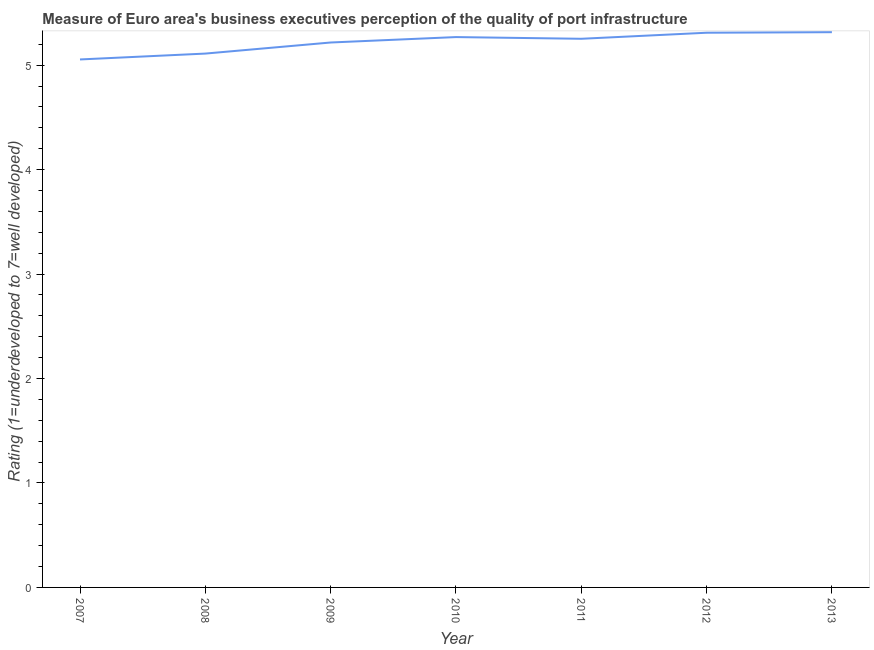What is the rating measuring quality of port infrastructure in 2007?
Your answer should be very brief. 5.05. Across all years, what is the maximum rating measuring quality of port infrastructure?
Provide a short and direct response. 5.32. Across all years, what is the minimum rating measuring quality of port infrastructure?
Make the answer very short. 5.05. In which year was the rating measuring quality of port infrastructure minimum?
Keep it short and to the point. 2007. What is the sum of the rating measuring quality of port infrastructure?
Offer a terse response. 36.53. What is the difference between the rating measuring quality of port infrastructure in 2007 and 2012?
Make the answer very short. -0.26. What is the average rating measuring quality of port infrastructure per year?
Ensure brevity in your answer.  5.22. What is the median rating measuring quality of port infrastructure?
Your response must be concise. 5.25. What is the ratio of the rating measuring quality of port infrastructure in 2007 to that in 2008?
Provide a succinct answer. 0.99. What is the difference between the highest and the second highest rating measuring quality of port infrastructure?
Provide a short and direct response. 0.01. Is the sum of the rating measuring quality of port infrastructure in 2009 and 2010 greater than the maximum rating measuring quality of port infrastructure across all years?
Give a very brief answer. Yes. What is the difference between the highest and the lowest rating measuring quality of port infrastructure?
Provide a short and direct response. 0.26. How many lines are there?
Make the answer very short. 1. How many years are there in the graph?
Your answer should be compact. 7. What is the difference between two consecutive major ticks on the Y-axis?
Ensure brevity in your answer.  1. What is the title of the graph?
Your answer should be compact. Measure of Euro area's business executives perception of the quality of port infrastructure. What is the label or title of the Y-axis?
Provide a short and direct response. Rating (1=underdeveloped to 7=well developed) . What is the Rating (1=underdeveloped to 7=well developed)  in 2007?
Provide a succinct answer. 5.05. What is the Rating (1=underdeveloped to 7=well developed)  of 2008?
Ensure brevity in your answer.  5.11. What is the Rating (1=underdeveloped to 7=well developed)  of 2009?
Offer a terse response. 5.22. What is the Rating (1=underdeveloped to 7=well developed)  in 2010?
Your answer should be compact. 5.27. What is the Rating (1=underdeveloped to 7=well developed)  of 2011?
Provide a succinct answer. 5.25. What is the Rating (1=underdeveloped to 7=well developed)  of 2012?
Your response must be concise. 5.31. What is the Rating (1=underdeveloped to 7=well developed)  of 2013?
Ensure brevity in your answer.  5.32. What is the difference between the Rating (1=underdeveloped to 7=well developed)  in 2007 and 2008?
Ensure brevity in your answer.  -0.06. What is the difference between the Rating (1=underdeveloped to 7=well developed)  in 2007 and 2009?
Provide a short and direct response. -0.16. What is the difference between the Rating (1=underdeveloped to 7=well developed)  in 2007 and 2010?
Provide a short and direct response. -0.21. What is the difference between the Rating (1=underdeveloped to 7=well developed)  in 2007 and 2011?
Your answer should be compact. -0.2. What is the difference between the Rating (1=underdeveloped to 7=well developed)  in 2007 and 2012?
Keep it short and to the point. -0.26. What is the difference between the Rating (1=underdeveloped to 7=well developed)  in 2007 and 2013?
Provide a short and direct response. -0.26. What is the difference between the Rating (1=underdeveloped to 7=well developed)  in 2008 and 2009?
Give a very brief answer. -0.11. What is the difference between the Rating (1=underdeveloped to 7=well developed)  in 2008 and 2010?
Your answer should be compact. -0.16. What is the difference between the Rating (1=underdeveloped to 7=well developed)  in 2008 and 2011?
Your response must be concise. -0.14. What is the difference between the Rating (1=underdeveloped to 7=well developed)  in 2008 and 2012?
Your response must be concise. -0.2. What is the difference between the Rating (1=underdeveloped to 7=well developed)  in 2008 and 2013?
Your answer should be compact. -0.2. What is the difference between the Rating (1=underdeveloped to 7=well developed)  in 2009 and 2010?
Offer a very short reply. -0.05. What is the difference between the Rating (1=underdeveloped to 7=well developed)  in 2009 and 2011?
Give a very brief answer. -0.04. What is the difference between the Rating (1=underdeveloped to 7=well developed)  in 2009 and 2012?
Offer a very short reply. -0.09. What is the difference between the Rating (1=underdeveloped to 7=well developed)  in 2009 and 2013?
Provide a short and direct response. -0.1. What is the difference between the Rating (1=underdeveloped to 7=well developed)  in 2010 and 2011?
Provide a succinct answer. 0.02. What is the difference between the Rating (1=underdeveloped to 7=well developed)  in 2010 and 2012?
Your response must be concise. -0.04. What is the difference between the Rating (1=underdeveloped to 7=well developed)  in 2010 and 2013?
Make the answer very short. -0.05. What is the difference between the Rating (1=underdeveloped to 7=well developed)  in 2011 and 2012?
Offer a very short reply. -0.06. What is the difference between the Rating (1=underdeveloped to 7=well developed)  in 2011 and 2013?
Provide a short and direct response. -0.06. What is the difference between the Rating (1=underdeveloped to 7=well developed)  in 2012 and 2013?
Give a very brief answer. -0.01. What is the ratio of the Rating (1=underdeveloped to 7=well developed)  in 2007 to that in 2008?
Your response must be concise. 0.99. What is the ratio of the Rating (1=underdeveloped to 7=well developed)  in 2007 to that in 2011?
Offer a terse response. 0.96. What is the ratio of the Rating (1=underdeveloped to 7=well developed)  in 2007 to that in 2012?
Keep it short and to the point. 0.95. What is the ratio of the Rating (1=underdeveloped to 7=well developed)  in 2007 to that in 2013?
Provide a short and direct response. 0.95. What is the ratio of the Rating (1=underdeveloped to 7=well developed)  in 2008 to that in 2010?
Ensure brevity in your answer.  0.97. What is the ratio of the Rating (1=underdeveloped to 7=well developed)  in 2008 to that in 2011?
Offer a terse response. 0.97. What is the ratio of the Rating (1=underdeveloped to 7=well developed)  in 2008 to that in 2012?
Provide a short and direct response. 0.96. What is the ratio of the Rating (1=underdeveloped to 7=well developed)  in 2009 to that in 2011?
Give a very brief answer. 0.99. What is the ratio of the Rating (1=underdeveloped to 7=well developed)  in 2010 to that in 2011?
Your answer should be compact. 1. What is the ratio of the Rating (1=underdeveloped to 7=well developed)  in 2011 to that in 2013?
Keep it short and to the point. 0.99. What is the ratio of the Rating (1=underdeveloped to 7=well developed)  in 2012 to that in 2013?
Ensure brevity in your answer.  1. 